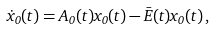<formula> <loc_0><loc_0><loc_500><loc_500>\dot { x } _ { 0 } ( t ) = A _ { 0 } ( t ) x _ { 0 } ( t ) - \bar { E } ( t ) x _ { 0 } ( t ) \, ,</formula> 